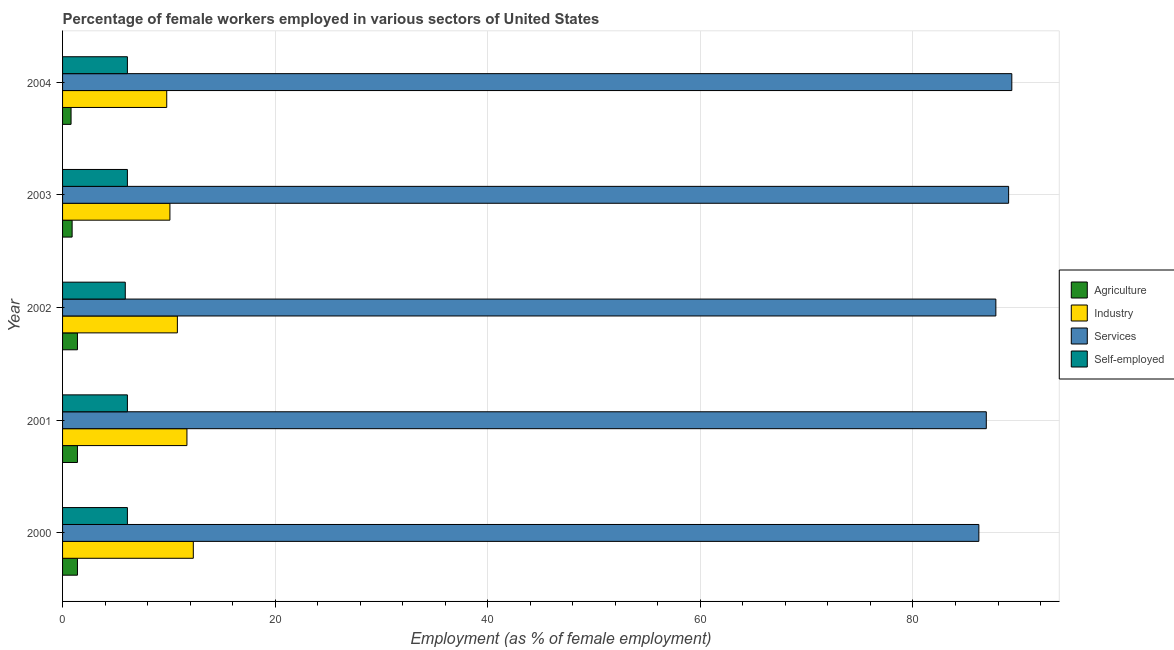How many groups of bars are there?
Your response must be concise. 5. How many bars are there on the 1st tick from the top?
Ensure brevity in your answer.  4. What is the label of the 5th group of bars from the top?
Ensure brevity in your answer.  2000. In how many cases, is the number of bars for a given year not equal to the number of legend labels?
Your response must be concise. 0. What is the percentage of female workers in industry in 2003?
Your answer should be compact. 10.1. Across all years, what is the maximum percentage of self employed female workers?
Ensure brevity in your answer.  6.1. Across all years, what is the minimum percentage of female workers in services?
Offer a terse response. 86.2. In which year was the percentage of self employed female workers maximum?
Offer a terse response. 2000. In which year was the percentage of female workers in services minimum?
Ensure brevity in your answer.  2000. What is the total percentage of female workers in services in the graph?
Offer a very short reply. 439.2. What is the difference between the percentage of self employed female workers in 2000 and that in 2001?
Keep it short and to the point. 0. What is the difference between the percentage of female workers in agriculture in 2002 and the percentage of female workers in services in 2003?
Keep it short and to the point. -87.6. What is the average percentage of female workers in agriculture per year?
Provide a short and direct response. 1.18. In the year 2004, what is the difference between the percentage of female workers in services and percentage of female workers in agriculture?
Ensure brevity in your answer.  88.5. What is the ratio of the percentage of female workers in services in 2000 to that in 2001?
Make the answer very short. 0.99. Is the percentage of female workers in services in 2000 less than that in 2001?
Provide a succinct answer. Yes. Is the difference between the percentage of self employed female workers in 2002 and 2004 greater than the difference between the percentage of female workers in services in 2002 and 2004?
Ensure brevity in your answer.  Yes. In how many years, is the percentage of female workers in services greater than the average percentage of female workers in services taken over all years?
Give a very brief answer. 2. Is the sum of the percentage of female workers in agriculture in 2002 and 2003 greater than the maximum percentage of female workers in industry across all years?
Offer a terse response. No. What does the 1st bar from the top in 2002 represents?
Make the answer very short. Self-employed. What does the 3rd bar from the bottom in 2001 represents?
Give a very brief answer. Services. Are all the bars in the graph horizontal?
Give a very brief answer. Yes. What is the difference between two consecutive major ticks on the X-axis?
Give a very brief answer. 20. Are the values on the major ticks of X-axis written in scientific E-notation?
Offer a terse response. No. Does the graph contain grids?
Provide a short and direct response. Yes. Where does the legend appear in the graph?
Keep it short and to the point. Center right. How are the legend labels stacked?
Your answer should be very brief. Vertical. What is the title of the graph?
Provide a succinct answer. Percentage of female workers employed in various sectors of United States. What is the label or title of the X-axis?
Provide a short and direct response. Employment (as % of female employment). What is the label or title of the Y-axis?
Ensure brevity in your answer.  Year. What is the Employment (as % of female employment) in Agriculture in 2000?
Keep it short and to the point. 1.4. What is the Employment (as % of female employment) in Industry in 2000?
Provide a short and direct response. 12.3. What is the Employment (as % of female employment) in Services in 2000?
Keep it short and to the point. 86.2. What is the Employment (as % of female employment) of Self-employed in 2000?
Ensure brevity in your answer.  6.1. What is the Employment (as % of female employment) of Agriculture in 2001?
Ensure brevity in your answer.  1.4. What is the Employment (as % of female employment) in Industry in 2001?
Give a very brief answer. 11.7. What is the Employment (as % of female employment) in Services in 2001?
Provide a succinct answer. 86.9. What is the Employment (as % of female employment) in Self-employed in 2001?
Keep it short and to the point. 6.1. What is the Employment (as % of female employment) in Agriculture in 2002?
Your answer should be compact. 1.4. What is the Employment (as % of female employment) in Industry in 2002?
Provide a succinct answer. 10.8. What is the Employment (as % of female employment) in Services in 2002?
Provide a succinct answer. 87.8. What is the Employment (as % of female employment) of Self-employed in 2002?
Offer a terse response. 5.9. What is the Employment (as % of female employment) in Agriculture in 2003?
Your answer should be compact. 0.9. What is the Employment (as % of female employment) in Industry in 2003?
Your response must be concise. 10.1. What is the Employment (as % of female employment) in Services in 2003?
Give a very brief answer. 89. What is the Employment (as % of female employment) of Self-employed in 2003?
Your answer should be compact. 6.1. What is the Employment (as % of female employment) of Agriculture in 2004?
Your answer should be very brief. 0.8. What is the Employment (as % of female employment) in Industry in 2004?
Make the answer very short. 9.8. What is the Employment (as % of female employment) in Services in 2004?
Your answer should be very brief. 89.3. What is the Employment (as % of female employment) in Self-employed in 2004?
Offer a very short reply. 6.1. Across all years, what is the maximum Employment (as % of female employment) of Agriculture?
Give a very brief answer. 1.4. Across all years, what is the maximum Employment (as % of female employment) in Industry?
Ensure brevity in your answer.  12.3. Across all years, what is the maximum Employment (as % of female employment) in Services?
Offer a terse response. 89.3. Across all years, what is the maximum Employment (as % of female employment) in Self-employed?
Give a very brief answer. 6.1. Across all years, what is the minimum Employment (as % of female employment) in Agriculture?
Provide a succinct answer. 0.8. Across all years, what is the minimum Employment (as % of female employment) of Industry?
Offer a very short reply. 9.8. Across all years, what is the minimum Employment (as % of female employment) of Services?
Keep it short and to the point. 86.2. Across all years, what is the minimum Employment (as % of female employment) of Self-employed?
Ensure brevity in your answer.  5.9. What is the total Employment (as % of female employment) in Agriculture in the graph?
Offer a very short reply. 5.9. What is the total Employment (as % of female employment) of Industry in the graph?
Offer a very short reply. 54.7. What is the total Employment (as % of female employment) in Services in the graph?
Your answer should be very brief. 439.2. What is the total Employment (as % of female employment) in Self-employed in the graph?
Give a very brief answer. 30.3. What is the difference between the Employment (as % of female employment) of Industry in 2000 and that in 2001?
Keep it short and to the point. 0.6. What is the difference between the Employment (as % of female employment) of Services in 2000 and that in 2001?
Your answer should be compact. -0.7. What is the difference between the Employment (as % of female employment) in Services in 2000 and that in 2002?
Make the answer very short. -1.6. What is the difference between the Employment (as % of female employment) in Self-employed in 2000 and that in 2002?
Ensure brevity in your answer.  0.2. What is the difference between the Employment (as % of female employment) of Agriculture in 2000 and that in 2003?
Provide a short and direct response. 0.5. What is the difference between the Employment (as % of female employment) of Industry in 2000 and that in 2003?
Your answer should be compact. 2.2. What is the difference between the Employment (as % of female employment) of Services in 2000 and that in 2003?
Your response must be concise. -2.8. What is the difference between the Employment (as % of female employment) of Industry in 2000 and that in 2004?
Provide a succinct answer. 2.5. What is the difference between the Employment (as % of female employment) of Agriculture in 2001 and that in 2002?
Give a very brief answer. 0. What is the difference between the Employment (as % of female employment) in Agriculture in 2001 and that in 2003?
Offer a very short reply. 0.5. What is the difference between the Employment (as % of female employment) of Agriculture in 2001 and that in 2004?
Your response must be concise. 0.6. What is the difference between the Employment (as % of female employment) of Services in 2001 and that in 2004?
Your answer should be very brief. -2.4. What is the difference between the Employment (as % of female employment) in Self-employed in 2001 and that in 2004?
Make the answer very short. 0. What is the difference between the Employment (as % of female employment) of Industry in 2002 and that in 2003?
Provide a succinct answer. 0.7. What is the difference between the Employment (as % of female employment) in Services in 2002 and that in 2003?
Offer a terse response. -1.2. What is the difference between the Employment (as % of female employment) of Agriculture in 2002 and that in 2004?
Your answer should be compact. 0.6. What is the difference between the Employment (as % of female employment) in Services in 2003 and that in 2004?
Your answer should be compact. -0.3. What is the difference between the Employment (as % of female employment) of Self-employed in 2003 and that in 2004?
Your response must be concise. 0. What is the difference between the Employment (as % of female employment) of Agriculture in 2000 and the Employment (as % of female employment) of Industry in 2001?
Provide a short and direct response. -10.3. What is the difference between the Employment (as % of female employment) of Agriculture in 2000 and the Employment (as % of female employment) of Services in 2001?
Ensure brevity in your answer.  -85.5. What is the difference between the Employment (as % of female employment) of Agriculture in 2000 and the Employment (as % of female employment) of Self-employed in 2001?
Offer a terse response. -4.7. What is the difference between the Employment (as % of female employment) of Industry in 2000 and the Employment (as % of female employment) of Services in 2001?
Provide a short and direct response. -74.6. What is the difference between the Employment (as % of female employment) in Industry in 2000 and the Employment (as % of female employment) in Self-employed in 2001?
Offer a terse response. 6.2. What is the difference between the Employment (as % of female employment) of Services in 2000 and the Employment (as % of female employment) of Self-employed in 2001?
Make the answer very short. 80.1. What is the difference between the Employment (as % of female employment) in Agriculture in 2000 and the Employment (as % of female employment) in Industry in 2002?
Your answer should be compact. -9.4. What is the difference between the Employment (as % of female employment) in Agriculture in 2000 and the Employment (as % of female employment) in Services in 2002?
Give a very brief answer. -86.4. What is the difference between the Employment (as % of female employment) in Industry in 2000 and the Employment (as % of female employment) in Services in 2002?
Your answer should be very brief. -75.5. What is the difference between the Employment (as % of female employment) of Industry in 2000 and the Employment (as % of female employment) of Self-employed in 2002?
Provide a short and direct response. 6.4. What is the difference between the Employment (as % of female employment) of Services in 2000 and the Employment (as % of female employment) of Self-employed in 2002?
Provide a succinct answer. 80.3. What is the difference between the Employment (as % of female employment) in Agriculture in 2000 and the Employment (as % of female employment) in Industry in 2003?
Your answer should be very brief. -8.7. What is the difference between the Employment (as % of female employment) in Agriculture in 2000 and the Employment (as % of female employment) in Services in 2003?
Offer a terse response. -87.6. What is the difference between the Employment (as % of female employment) of Agriculture in 2000 and the Employment (as % of female employment) of Self-employed in 2003?
Keep it short and to the point. -4.7. What is the difference between the Employment (as % of female employment) in Industry in 2000 and the Employment (as % of female employment) in Services in 2003?
Provide a succinct answer. -76.7. What is the difference between the Employment (as % of female employment) in Industry in 2000 and the Employment (as % of female employment) in Self-employed in 2003?
Ensure brevity in your answer.  6.2. What is the difference between the Employment (as % of female employment) of Services in 2000 and the Employment (as % of female employment) of Self-employed in 2003?
Your response must be concise. 80.1. What is the difference between the Employment (as % of female employment) in Agriculture in 2000 and the Employment (as % of female employment) in Industry in 2004?
Keep it short and to the point. -8.4. What is the difference between the Employment (as % of female employment) of Agriculture in 2000 and the Employment (as % of female employment) of Services in 2004?
Your answer should be very brief. -87.9. What is the difference between the Employment (as % of female employment) of Agriculture in 2000 and the Employment (as % of female employment) of Self-employed in 2004?
Keep it short and to the point. -4.7. What is the difference between the Employment (as % of female employment) in Industry in 2000 and the Employment (as % of female employment) in Services in 2004?
Keep it short and to the point. -77. What is the difference between the Employment (as % of female employment) in Industry in 2000 and the Employment (as % of female employment) in Self-employed in 2004?
Give a very brief answer. 6.2. What is the difference between the Employment (as % of female employment) in Services in 2000 and the Employment (as % of female employment) in Self-employed in 2004?
Provide a succinct answer. 80.1. What is the difference between the Employment (as % of female employment) of Agriculture in 2001 and the Employment (as % of female employment) of Services in 2002?
Keep it short and to the point. -86.4. What is the difference between the Employment (as % of female employment) in Industry in 2001 and the Employment (as % of female employment) in Services in 2002?
Ensure brevity in your answer.  -76.1. What is the difference between the Employment (as % of female employment) of Services in 2001 and the Employment (as % of female employment) of Self-employed in 2002?
Keep it short and to the point. 81. What is the difference between the Employment (as % of female employment) in Agriculture in 2001 and the Employment (as % of female employment) in Industry in 2003?
Your answer should be compact. -8.7. What is the difference between the Employment (as % of female employment) of Agriculture in 2001 and the Employment (as % of female employment) of Services in 2003?
Ensure brevity in your answer.  -87.6. What is the difference between the Employment (as % of female employment) in Agriculture in 2001 and the Employment (as % of female employment) in Self-employed in 2003?
Provide a short and direct response. -4.7. What is the difference between the Employment (as % of female employment) in Industry in 2001 and the Employment (as % of female employment) in Services in 2003?
Keep it short and to the point. -77.3. What is the difference between the Employment (as % of female employment) in Services in 2001 and the Employment (as % of female employment) in Self-employed in 2003?
Your answer should be compact. 80.8. What is the difference between the Employment (as % of female employment) in Agriculture in 2001 and the Employment (as % of female employment) in Services in 2004?
Provide a short and direct response. -87.9. What is the difference between the Employment (as % of female employment) of Agriculture in 2001 and the Employment (as % of female employment) of Self-employed in 2004?
Your response must be concise. -4.7. What is the difference between the Employment (as % of female employment) of Industry in 2001 and the Employment (as % of female employment) of Services in 2004?
Your answer should be compact. -77.6. What is the difference between the Employment (as % of female employment) in Services in 2001 and the Employment (as % of female employment) in Self-employed in 2004?
Offer a terse response. 80.8. What is the difference between the Employment (as % of female employment) of Agriculture in 2002 and the Employment (as % of female employment) of Industry in 2003?
Give a very brief answer. -8.7. What is the difference between the Employment (as % of female employment) of Agriculture in 2002 and the Employment (as % of female employment) of Services in 2003?
Your answer should be compact. -87.6. What is the difference between the Employment (as % of female employment) in Agriculture in 2002 and the Employment (as % of female employment) in Self-employed in 2003?
Provide a short and direct response. -4.7. What is the difference between the Employment (as % of female employment) in Industry in 2002 and the Employment (as % of female employment) in Services in 2003?
Provide a succinct answer. -78.2. What is the difference between the Employment (as % of female employment) in Services in 2002 and the Employment (as % of female employment) in Self-employed in 2003?
Offer a terse response. 81.7. What is the difference between the Employment (as % of female employment) of Agriculture in 2002 and the Employment (as % of female employment) of Services in 2004?
Your response must be concise. -87.9. What is the difference between the Employment (as % of female employment) of Agriculture in 2002 and the Employment (as % of female employment) of Self-employed in 2004?
Your answer should be compact. -4.7. What is the difference between the Employment (as % of female employment) of Industry in 2002 and the Employment (as % of female employment) of Services in 2004?
Your response must be concise. -78.5. What is the difference between the Employment (as % of female employment) of Services in 2002 and the Employment (as % of female employment) of Self-employed in 2004?
Make the answer very short. 81.7. What is the difference between the Employment (as % of female employment) in Agriculture in 2003 and the Employment (as % of female employment) in Services in 2004?
Provide a succinct answer. -88.4. What is the difference between the Employment (as % of female employment) of Industry in 2003 and the Employment (as % of female employment) of Services in 2004?
Provide a succinct answer. -79.2. What is the difference between the Employment (as % of female employment) in Services in 2003 and the Employment (as % of female employment) in Self-employed in 2004?
Your answer should be compact. 82.9. What is the average Employment (as % of female employment) of Agriculture per year?
Make the answer very short. 1.18. What is the average Employment (as % of female employment) of Industry per year?
Your answer should be compact. 10.94. What is the average Employment (as % of female employment) of Services per year?
Your response must be concise. 87.84. What is the average Employment (as % of female employment) of Self-employed per year?
Offer a very short reply. 6.06. In the year 2000, what is the difference between the Employment (as % of female employment) of Agriculture and Employment (as % of female employment) of Services?
Your answer should be compact. -84.8. In the year 2000, what is the difference between the Employment (as % of female employment) in Industry and Employment (as % of female employment) in Services?
Provide a succinct answer. -73.9. In the year 2000, what is the difference between the Employment (as % of female employment) of Industry and Employment (as % of female employment) of Self-employed?
Your answer should be very brief. 6.2. In the year 2000, what is the difference between the Employment (as % of female employment) of Services and Employment (as % of female employment) of Self-employed?
Your answer should be compact. 80.1. In the year 2001, what is the difference between the Employment (as % of female employment) in Agriculture and Employment (as % of female employment) in Services?
Give a very brief answer. -85.5. In the year 2001, what is the difference between the Employment (as % of female employment) in Agriculture and Employment (as % of female employment) in Self-employed?
Your answer should be compact. -4.7. In the year 2001, what is the difference between the Employment (as % of female employment) of Industry and Employment (as % of female employment) of Services?
Your answer should be very brief. -75.2. In the year 2001, what is the difference between the Employment (as % of female employment) in Services and Employment (as % of female employment) in Self-employed?
Make the answer very short. 80.8. In the year 2002, what is the difference between the Employment (as % of female employment) of Agriculture and Employment (as % of female employment) of Industry?
Offer a very short reply. -9.4. In the year 2002, what is the difference between the Employment (as % of female employment) in Agriculture and Employment (as % of female employment) in Services?
Offer a very short reply. -86.4. In the year 2002, what is the difference between the Employment (as % of female employment) in Industry and Employment (as % of female employment) in Services?
Provide a succinct answer. -77. In the year 2002, what is the difference between the Employment (as % of female employment) of Services and Employment (as % of female employment) of Self-employed?
Ensure brevity in your answer.  81.9. In the year 2003, what is the difference between the Employment (as % of female employment) of Agriculture and Employment (as % of female employment) of Services?
Keep it short and to the point. -88.1. In the year 2003, what is the difference between the Employment (as % of female employment) in Industry and Employment (as % of female employment) in Services?
Provide a short and direct response. -78.9. In the year 2003, what is the difference between the Employment (as % of female employment) in Industry and Employment (as % of female employment) in Self-employed?
Provide a succinct answer. 4. In the year 2003, what is the difference between the Employment (as % of female employment) in Services and Employment (as % of female employment) in Self-employed?
Your answer should be compact. 82.9. In the year 2004, what is the difference between the Employment (as % of female employment) of Agriculture and Employment (as % of female employment) of Industry?
Your response must be concise. -9. In the year 2004, what is the difference between the Employment (as % of female employment) in Agriculture and Employment (as % of female employment) in Services?
Your response must be concise. -88.5. In the year 2004, what is the difference between the Employment (as % of female employment) of Agriculture and Employment (as % of female employment) of Self-employed?
Keep it short and to the point. -5.3. In the year 2004, what is the difference between the Employment (as % of female employment) of Industry and Employment (as % of female employment) of Services?
Ensure brevity in your answer.  -79.5. In the year 2004, what is the difference between the Employment (as % of female employment) in Services and Employment (as % of female employment) in Self-employed?
Offer a very short reply. 83.2. What is the ratio of the Employment (as % of female employment) in Industry in 2000 to that in 2001?
Ensure brevity in your answer.  1.05. What is the ratio of the Employment (as % of female employment) of Services in 2000 to that in 2001?
Provide a short and direct response. 0.99. What is the ratio of the Employment (as % of female employment) of Agriculture in 2000 to that in 2002?
Your response must be concise. 1. What is the ratio of the Employment (as % of female employment) in Industry in 2000 to that in 2002?
Make the answer very short. 1.14. What is the ratio of the Employment (as % of female employment) in Services in 2000 to that in 2002?
Offer a terse response. 0.98. What is the ratio of the Employment (as % of female employment) of Self-employed in 2000 to that in 2002?
Ensure brevity in your answer.  1.03. What is the ratio of the Employment (as % of female employment) in Agriculture in 2000 to that in 2003?
Your answer should be very brief. 1.56. What is the ratio of the Employment (as % of female employment) of Industry in 2000 to that in 2003?
Your response must be concise. 1.22. What is the ratio of the Employment (as % of female employment) of Services in 2000 to that in 2003?
Your answer should be compact. 0.97. What is the ratio of the Employment (as % of female employment) of Self-employed in 2000 to that in 2003?
Offer a very short reply. 1. What is the ratio of the Employment (as % of female employment) of Agriculture in 2000 to that in 2004?
Make the answer very short. 1.75. What is the ratio of the Employment (as % of female employment) of Industry in 2000 to that in 2004?
Your answer should be very brief. 1.26. What is the ratio of the Employment (as % of female employment) in Services in 2000 to that in 2004?
Provide a short and direct response. 0.97. What is the ratio of the Employment (as % of female employment) of Self-employed in 2000 to that in 2004?
Give a very brief answer. 1. What is the ratio of the Employment (as % of female employment) in Agriculture in 2001 to that in 2002?
Make the answer very short. 1. What is the ratio of the Employment (as % of female employment) of Industry in 2001 to that in 2002?
Offer a very short reply. 1.08. What is the ratio of the Employment (as % of female employment) in Services in 2001 to that in 2002?
Provide a succinct answer. 0.99. What is the ratio of the Employment (as % of female employment) of Self-employed in 2001 to that in 2002?
Provide a succinct answer. 1.03. What is the ratio of the Employment (as % of female employment) in Agriculture in 2001 to that in 2003?
Offer a very short reply. 1.56. What is the ratio of the Employment (as % of female employment) of Industry in 2001 to that in 2003?
Your answer should be very brief. 1.16. What is the ratio of the Employment (as % of female employment) of Services in 2001 to that in 2003?
Offer a very short reply. 0.98. What is the ratio of the Employment (as % of female employment) in Industry in 2001 to that in 2004?
Ensure brevity in your answer.  1.19. What is the ratio of the Employment (as % of female employment) of Services in 2001 to that in 2004?
Give a very brief answer. 0.97. What is the ratio of the Employment (as % of female employment) of Self-employed in 2001 to that in 2004?
Give a very brief answer. 1. What is the ratio of the Employment (as % of female employment) of Agriculture in 2002 to that in 2003?
Ensure brevity in your answer.  1.56. What is the ratio of the Employment (as % of female employment) in Industry in 2002 to that in 2003?
Your answer should be compact. 1.07. What is the ratio of the Employment (as % of female employment) in Services in 2002 to that in 2003?
Your response must be concise. 0.99. What is the ratio of the Employment (as % of female employment) in Self-employed in 2002 to that in 2003?
Your answer should be very brief. 0.97. What is the ratio of the Employment (as % of female employment) of Industry in 2002 to that in 2004?
Your answer should be very brief. 1.1. What is the ratio of the Employment (as % of female employment) in Services in 2002 to that in 2004?
Make the answer very short. 0.98. What is the ratio of the Employment (as % of female employment) of Self-employed in 2002 to that in 2004?
Offer a very short reply. 0.97. What is the ratio of the Employment (as % of female employment) of Agriculture in 2003 to that in 2004?
Make the answer very short. 1.12. What is the ratio of the Employment (as % of female employment) of Industry in 2003 to that in 2004?
Give a very brief answer. 1.03. What is the ratio of the Employment (as % of female employment) in Self-employed in 2003 to that in 2004?
Keep it short and to the point. 1. What is the difference between the highest and the second highest Employment (as % of female employment) of Agriculture?
Offer a terse response. 0. What is the difference between the highest and the second highest Employment (as % of female employment) of Industry?
Give a very brief answer. 0.6. What is the difference between the highest and the second highest Employment (as % of female employment) of Services?
Your answer should be very brief. 0.3. What is the difference between the highest and the lowest Employment (as % of female employment) in Services?
Your response must be concise. 3.1. What is the difference between the highest and the lowest Employment (as % of female employment) in Self-employed?
Provide a succinct answer. 0.2. 